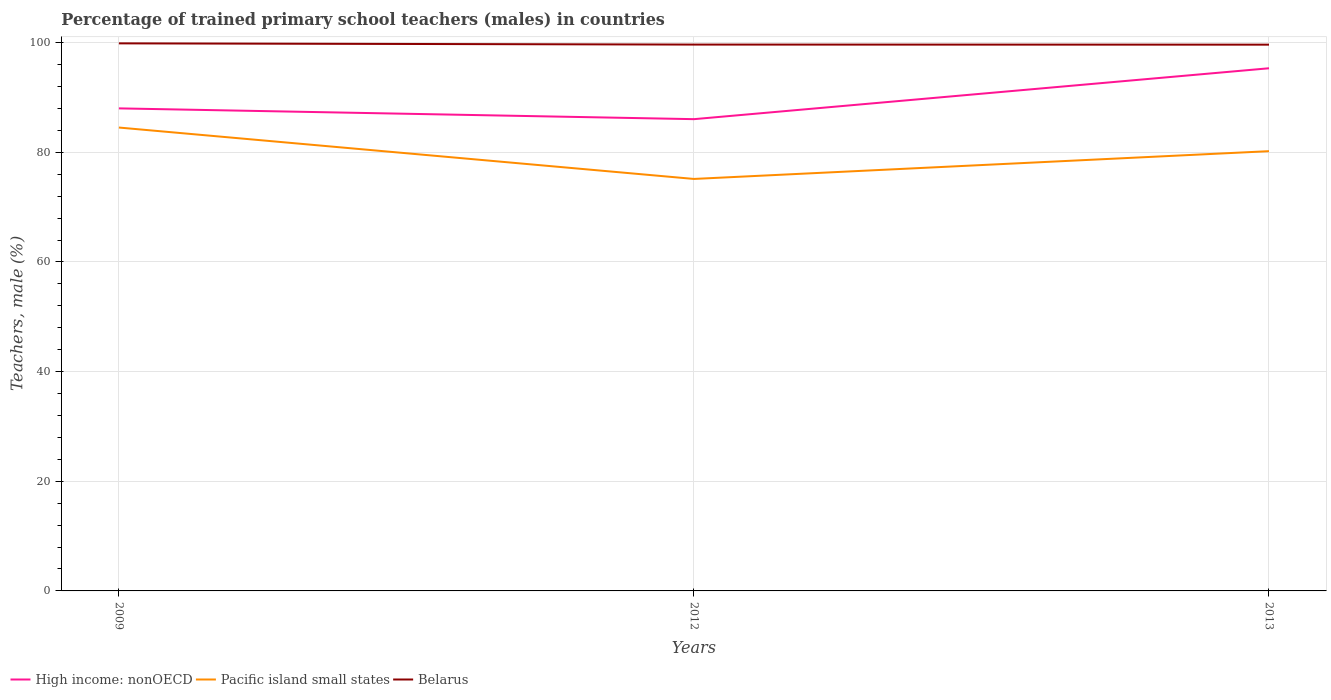How many different coloured lines are there?
Provide a short and direct response. 3. Does the line corresponding to Pacific island small states intersect with the line corresponding to High income: nonOECD?
Your answer should be very brief. No. Across all years, what is the maximum percentage of trained primary school teachers (males) in Pacific island small states?
Your answer should be compact. 75.14. What is the total percentage of trained primary school teachers (males) in Belarus in the graph?
Keep it short and to the point. 0.24. What is the difference between the highest and the second highest percentage of trained primary school teachers (males) in High income: nonOECD?
Your answer should be compact. 9.28. What is the difference between the highest and the lowest percentage of trained primary school teachers (males) in Pacific island small states?
Provide a short and direct response. 2. Is the percentage of trained primary school teachers (males) in High income: nonOECD strictly greater than the percentage of trained primary school teachers (males) in Pacific island small states over the years?
Your response must be concise. No. How many lines are there?
Your response must be concise. 3. What is the difference between two consecutive major ticks on the Y-axis?
Provide a short and direct response. 20. Where does the legend appear in the graph?
Ensure brevity in your answer.  Bottom left. How many legend labels are there?
Keep it short and to the point. 3. What is the title of the graph?
Provide a succinct answer. Percentage of trained primary school teachers (males) in countries. What is the label or title of the X-axis?
Keep it short and to the point. Years. What is the label or title of the Y-axis?
Provide a succinct answer. Teachers, male (%). What is the Teachers, male (%) of High income: nonOECD in 2009?
Your answer should be very brief. 88.01. What is the Teachers, male (%) of Pacific island small states in 2009?
Give a very brief answer. 84.51. What is the Teachers, male (%) of Belarus in 2009?
Your answer should be compact. 99.87. What is the Teachers, male (%) in High income: nonOECD in 2012?
Your answer should be compact. 86.04. What is the Teachers, male (%) in Pacific island small states in 2012?
Your answer should be compact. 75.14. What is the Teachers, male (%) of Belarus in 2012?
Keep it short and to the point. 99.64. What is the Teachers, male (%) of High income: nonOECD in 2013?
Your response must be concise. 95.32. What is the Teachers, male (%) of Pacific island small states in 2013?
Ensure brevity in your answer.  80.2. What is the Teachers, male (%) in Belarus in 2013?
Ensure brevity in your answer.  99.63. Across all years, what is the maximum Teachers, male (%) in High income: nonOECD?
Provide a succinct answer. 95.32. Across all years, what is the maximum Teachers, male (%) in Pacific island small states?
Keep it short and to the point. 84.51. Across all years, what is the maximum Teachers, male (%) in Belarus?
Offer a terse response. 99.87. Across all years, what is the minimum Teachers, male (%) of High income: nonOECD?
Your answer should be very brief. 86.04. Across all years, what is the minimum Teachers, male (%) of Pacific island small states?
Provide a short and direct response. 75.14. Across all years, what is the minimum Teachers, male (%) in Belarus?
Offer a very short reply. 99.63. What is the total Teachers, male (%) in High income: nonOECD in the graph?
Make the answer very short. 269.37. What is the total Teachers, male (%) of Pacific island small states in the graph?
Your answer should be compact. 239.85. What is the total Teachers, male (%) in Belarus in the graph?
Give a very brief answer. 299.13. What is the difference between the Teachers, male (%) of High income: nonOECD in 2009 and that in 2012?
Your answer should be compact. 1.97. What is the difference between the Teachers, male (%) in Pacific island small states in 2009 and that in 2012?
Your answer should be compact. 9.37. What is the difference between the Teachers, male (%) of Belarus in 2009 and that in 2012?
Offer a terse response. 0.22. What is the difference between the Teachers, male (%) of High income: nonOECD in 2009 and that in 2013?
Provide a short and direct response. -7.32. What is the difference between the Teachers, male (%) in Pacific island small states in 2009 and that in 2013?
Keep it short and to the point. 4.31. What is the difference between the Teachers, male (%) of Belarus in 2009 and that in 2013?
Provide a short and direct response. 0.24. What is the difference between the Teachers, male (%) in High income: nonOECD in 2012 and that in 2013?
Offer a terse response. -9.28. What is the difference between the Teachers, male (%) in Pacific island small states in 2012 and that in 2013?
Offer a terse response. -5.07. What is the difference between the Teachers, male (%) in Belarus in 2012 and that in 2013?
Provide a short and direct response. 0.02. What is the difference between the Teachers, male (%) of High income: nonOECD in 2009 and the Teachers, male (%) of Pacific island small states in 2012?
Keep it short and to the point. 12.87. What is the difference between the Teachers, male (%) of High income: nonOECD in 2009 and the Teachers, male (%) of Belarus in 2012?
Your response must be concise. -11.64. What is the difference between the Teachers, male (%) of Pacific island small states in 2009 and the Teachers, male (%) of Belarus in 2012?
Your answer should be compact. -15.13. What is the difference between the Teachers, male (%) of High income: nonOECD in 2009 and the Teachers, male (%) of Pacific island small states in 2013?
Ensure brevity in your answer.  7.8. What is the difference between the Teachers, male (%) of High income: nonOECD in 2009 and the Teachers, male (%) of Belarus in 2013?
Your response must be concise. -11.62. What is the difference between the Teachers, male (%) of Pacific island small states in 2009 and the Teachers, male (%) of Belarus in 2013?
Ensure brevity in your answer.  -15.12. What is the difference between the Teachers, male (%) of High income: nonOECD in 2012 and the Teachers, male (%) of Pacific island small states in 2013?
Offer a terse response. 5.84. What is the difference between the Teachers, male (%) of High income: nonOECD in 2012 and the Teachers, male (%) of Belarus in 2013?
Offer a very short reply. -13.59. What is the difference between the Teachers, male (%) of Pacific island small states in 2012 and the Teachers, male (%) of Belarus in 2013?
Give a very brief answer. -24.49. What is the average Teachers, male (%) of High income: nonOECD per year?
Keep it short and to the point. 89.79. What is the average Teachers, male (%) in Pacific island small states per year?
Offer a terse response. 79.95. What is the average Teachers, male (%) in Belarus per year?
Offer a terse response. 99.71. In the year 2009, what is the difference between the Teachers, male (%) of High income: nonOECD and Teachers, male (%) of Pacific island small states?
Provide a short and direct response. 3.49. In the year 2009, what is the difference between the Teachers, male (%) in High income: nonOECD and Teachers, male (%) in Belarus?
Make the answer very short. -11.86. In the year 2009, what is the difference between the Teachers, male (%) of Pacific island small states and Teachers, male (%) of Belarus?
Your response must be concise. -15.35. In the year 2012, what is the difference between the Teachers, male (%) of High income: nonOECD and Teachers, male (%) of Pacific island small states?
Give a very brief answer. 10.9. In the year 2012, what is the difference between the Teachers, male (%) in High income: nonOECD and Teachers, male (%) in Belarus?
Your response must be concise. -13.6. In the year 2012, what is the difference between the Teachers, male (%) in Pacific island small states and Teachers, male (%) in Belarus?
Give a very brief answer. -24.5. In the year 2013, what is the difference between the Teachers, male (%) of High income: nonOECD and Teachers, male (%) of Pacific island small states?
Your answer should be very brief. 15.12. In the year 2013, what is the difference between the Teachers, male (%) in High income: nonOECD and Teachers, male (%) in Belarus?
Make the answer very short. -4.3. In the year 2013, what is the difference between the Teachers, male (%) of Pacific island small states and Teachers, male (%) of Belarus?
Your answer should be compact. -19.42. What is the ratio of the Teachers, male (%) of High income: nonOECD in 2009 to that in 2012?
Offer a very short reply. 1.02. What is the ratio of the Teachers, male (%) of Pacific island small states in 2009 to that in 2012?
Your answer should be very brief. 1.12. What is the ratio of the Teachers, male (%) in High income: nonOECD in 2009 to that in 2013?
Your answer should be very brief. 0.92. What is the ratio of the Teachers, male (%) in Pacific island small states in 2009 to that in 2013?
Offer a very short reply. 1.05. What is the ratio of the Teachers, male (%) of Belarus in 2009 to that in 2013?
Ensure brevity in your answer.  1. What is the ratio of the Teachers, male (%) in High income: nonOECD in 2012 to that in 2013?
Your response must be concise. 0.9. What is the ratio of the Teachers, male (%) of Pacific island small states in 2012 to that in 2013?
Your answer should be very brief. 0.94. What is the ratio of the Teachers, male (%) in Belarus in 2012 to that in 2013?
Offer a terse response. 1. What is the difference between the highest and the second highest Teachers, male (%) in High income: nonOECD?
Provide a short and direct response. 7.32. What is the difference between the highest and the second highest Teachers, male (%) of Pacific island small states?
Your response must be concise. 4.31. What is the difference between the highest and the second highest Teachers, male (%) in Belarus?
Give a very brief answer. 0.22. What is the difference between the highest and the lowest Teachers, male (%) of High income: nonOECD?
Your answer should be very brief. 9.28. What is the difference between the highest and the lowest Teachers, male (%) of Pacific island small states?
Keep it short and to the point. 9.37. What is the difference between the highest and the lowest Teachers, male (%) in Belarus?
Your response must be concise. 0.24. 